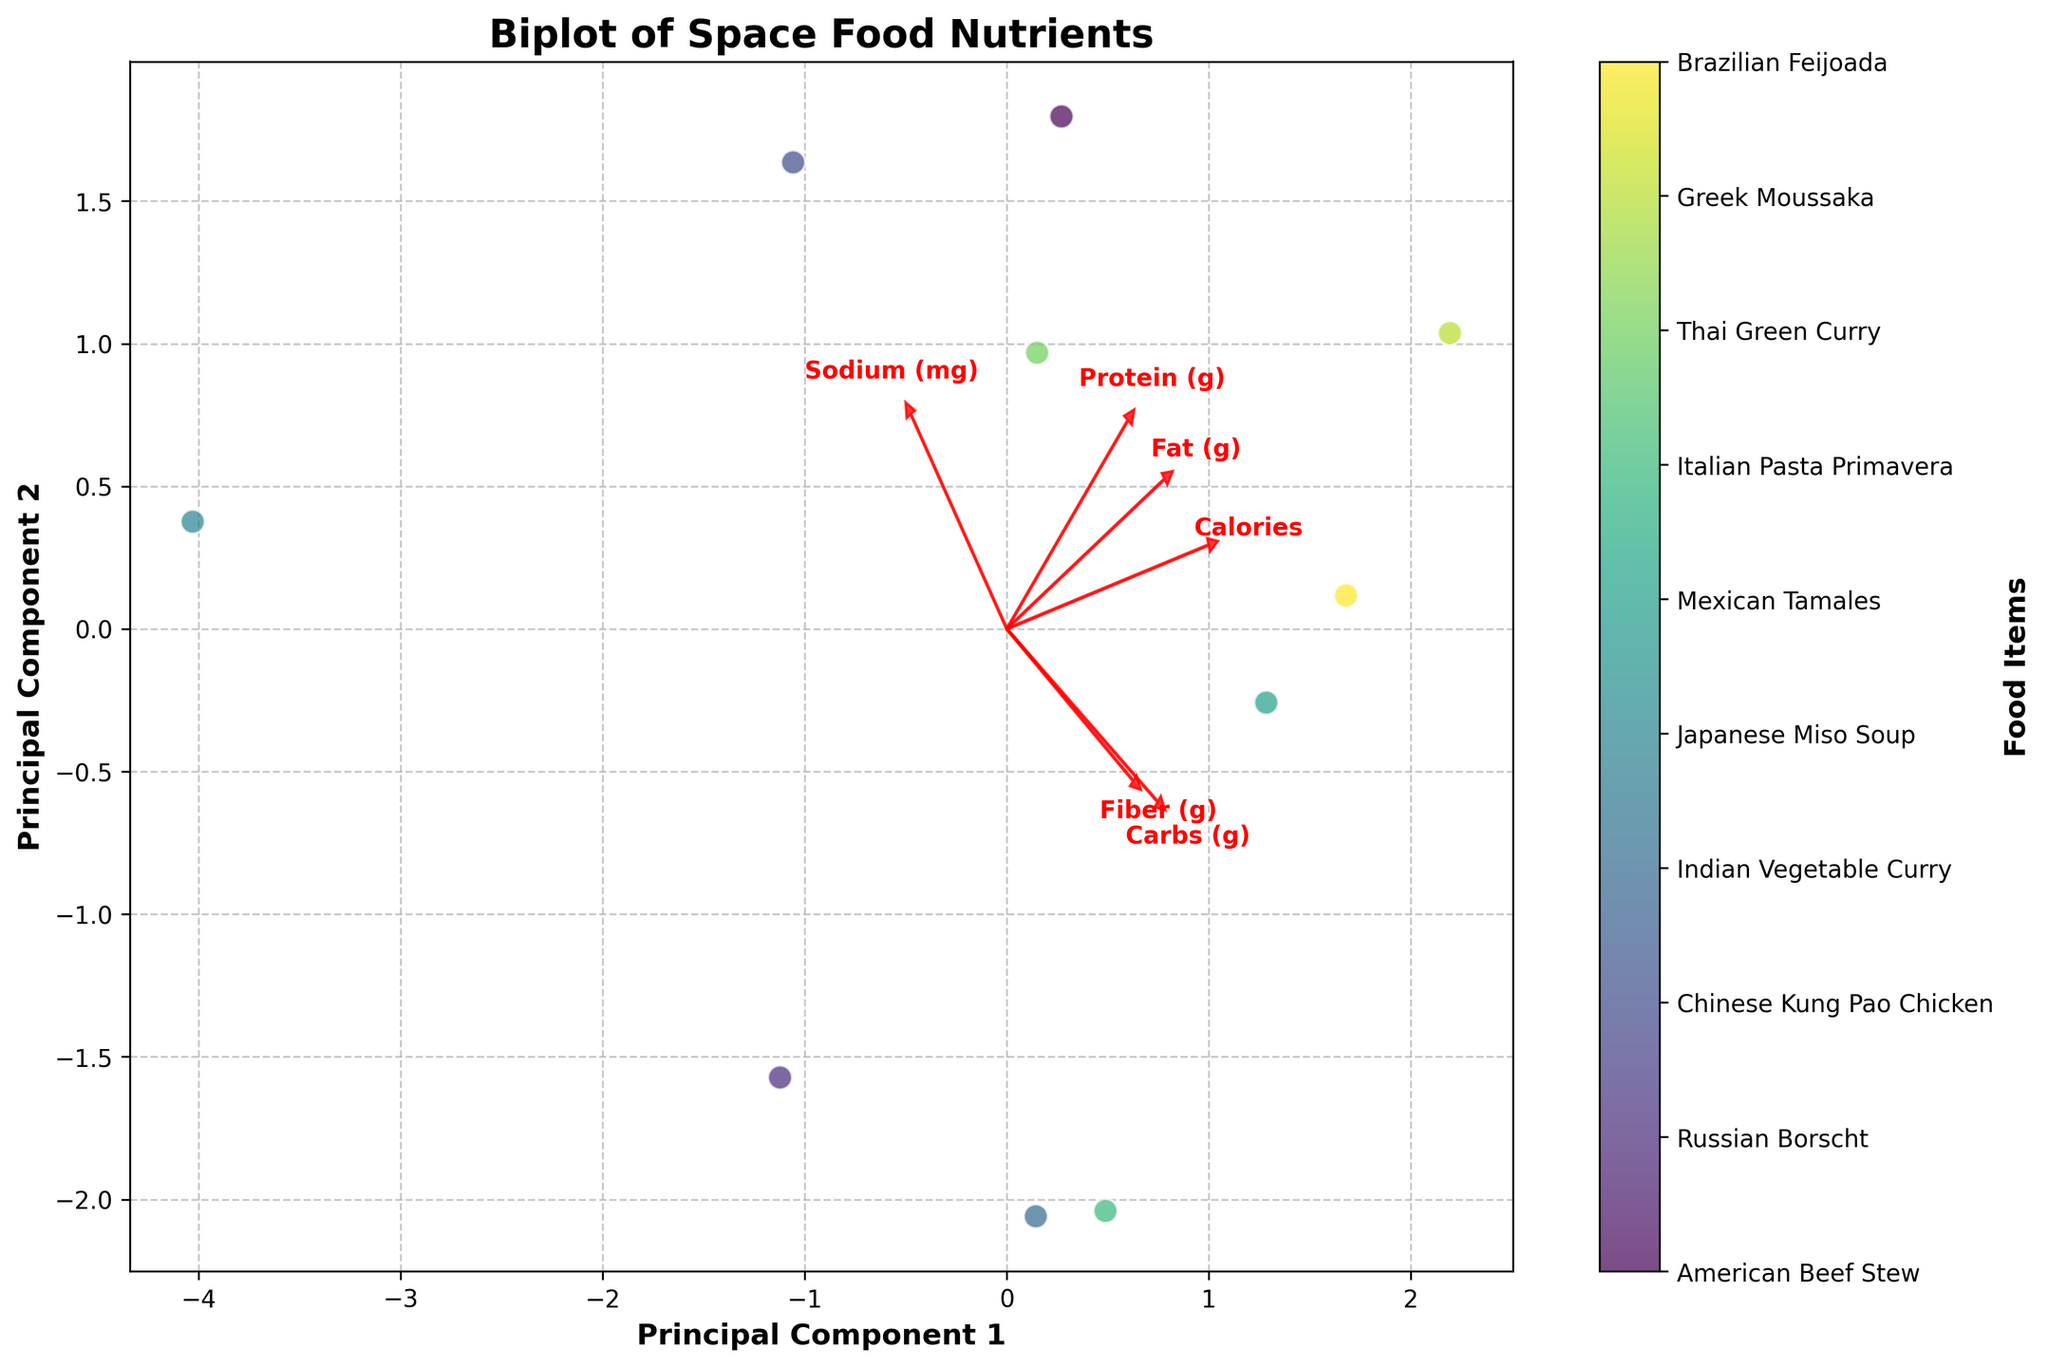What is the title of the plot? The title is typically located at the top of the plot and provides a summary of what the plot represents. In this case, it reads "Biplot of Space Food Nutrients".
Answer: Biplot of Space Food Nutrients What does the x-axis represent? The label on the x-axis indicates it represents "Principal Component 1". This is the first principal component derived from the PCA, capturing the most variance in the data.
Answer: Principal Component 1 How many food items are represented in the plot? Each data point corresponds to a unique food item. By observing the number of distinct points (or the range of colors), we can determine the number. The color bar provides labels for all items, implying 10 data points.
Answer: 10 Which nutrient has the highest positive loading on Principal Component 1? Nutrient loadings on Principal Component 1 can be discerned by looking at the direction and length of the eigenvectors (arrows). The arrow with the highest positive component along the x-axis points to "Protein (g)".
Answer: Protein (g) Which food item has the highest positive score on Principal Component 1? The food item farthest to the right on the x-axis (Principal Component 1) has the highest positive score. Observing the data points, "Greek Moussaka" is positioned the farthest to the right.
Answer: Greek Moussaka How does "Mexican Tamales" compare to "Russian Borscht" in terms of Principal Component 1 and Principal Component 2? Locate both "Mexican Tamales" and "Russian Borscht" on the plot. "Mexican Tamales" is higher along both PC1 and PC2 whereas "Russian Borscht" is lower on both axes.
Answer: Higher on both PC1 and PC2 Is the vector for "Fiber (g)" more aligned with Principal Component 1 or Principal Component 2? The alignment is judged by the direction and length. Since the "Fiber (g)" arrow points more towards the direction of the y-axis (PC2), it aligns more with PC2.
Answer: Principal Component 2 Which nutrients are positively correlated based on the plot? Nutrients whose arrows point approximately in the same direction have positive correlation. "Fiber (g)" and "Carbs (g)" point in a similar direction, indicating positive correlation.
Answer: Fiber (g) and Carbs (g) Explain the relationship between "Calories" and "Fat (g)" as depicted in the plot. The directions of "Calories" and "Fat (g)" vectors are similar, indicating a positive relationship. Thus, as the calorie content increases, fat content also tends to increase.
Answer: Positive relationship Which food item appears to have the lowest score on both Principal Component 1 and Principal Component 2? The data point that is closest to the origin (0,0) and particularly lower on both axes is likely to have the lowest score in both components. "Japanese Miso Soup" fits this description.
Answer: Japanese Miso Soup 